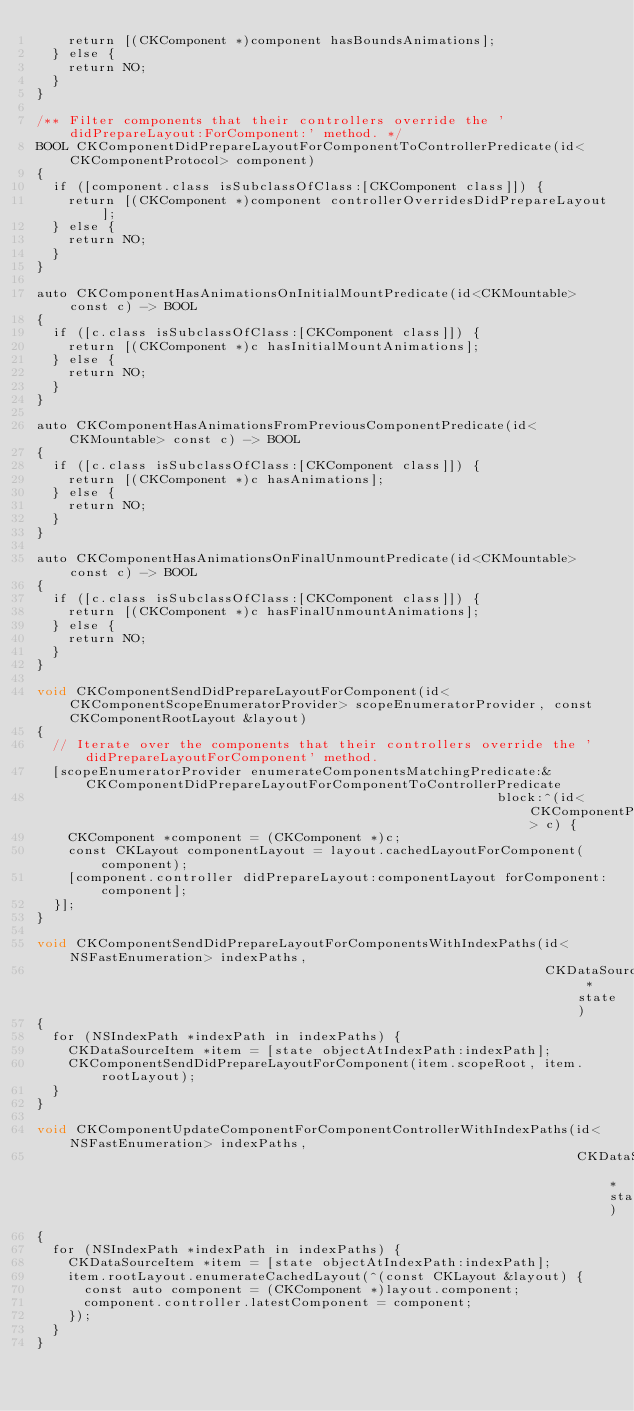Convert code to text. <code><loc_0><loc_0><loc_500><loc_500><_ObjectiveC_>    return [(CKComponent *)component hasBoundsAnimations];
  } else {
    return NO;
  }
}

/** Filter components that their controllers override the 'didPrepareLayout:ForComponent:' method. */
BOOL CKComponentDidPrepareLayoutForComponentToControllerPredicate(id<CKComponentProtocol> component)
{
  if ([component.class isSubclassOfClass:[CKComponent class]]) {
    return [(CKComponent *)component controllerOverridesDidPrepareLayout];
  } else {
    return NO;
  }
}

auto CKComponentHasAnimationsOnInitialMountPredicate(id<CKMountable> const c) -> BOOL
{
  if ([c.class isSubclassOfClass:[CKComponent class]]) {
    return [(CKComponent *)c hasInitialMountAnimations];
  } else {
    return NO;
  }
}

auto CKComponentHasAnimationsFromPreviousComponentPredicate(id<CKMountable> const c) -> BOOL
{
  if ([c.class isSubclassOfClass:[CKComponent class]]) {
    return [(CKComponent *)c hasAnimations];
  } else {
    return NO;
  }
}

auto CKComponentHasAnimationsOnFinalUnmountPredicate(id<CKMountable> const c) -> BOOL
{
  if ([c.class isSubclassOfClass:[CKComponent class]]) {
    return [(CKComponent *)c hasFinalUnmountAnimations];
  } else {
    return NO;
  }
}

void CKComponentSendDidPrepareLayoutForComponent(id<CKComponentScopeEnumeratorProvider> scopeEnumeratorProvider, const CKComponentRootLayout &layout)
{
  // Iterate over the components that their controllers override the 'didPrepareLayoutForComponent' method.
  [scopeEnumeratorProvider enumerateComponentsMatchingPredicate:&CKComponentDidPrepareLayoutForComponentToControllerPredicate
                                                          block:^(id<CKComponentProtocol> c) {
    CKComponent *component = (CKComponent *)c;
    const CKLayout componentLayout = layout.cachedLayoutForComponent(component);
    [component.controller didPrepareLayout:componentLayout forComponent:component];
  }];
}

void CKComponentSendDidPrepareLayoutForComponentsWithIndexPaths(id<NSFastEnumeration> indexPaths,
                                                                CKDataSourceState *state)
{
  for (NSIndexPath *indexPath in indexPaths) {
    CKDataSourceItem *item = [state objectAtIndexPath:indexPath];
    CKComponentSendDidPrepareLayoutForComponent(item.scopeRoot, item.rootLayout);
  }
}

void CKComponentUpdateComponentForComponentControllerWithIndexPaths(id<NSFastEnumeration> indexPaths,
                                                                    CKDataSourceState *state)
{
  for (NSIndexPath *indexPath in indexPaths) {
    CKDataSourceItem *item = [state objectAtIndexPath:indexPath];
    item.rootLayout.enumerateCachedLayout(^(const CKLayout &layout) {
      const auto component = (CKComponent *)layout.component;
      component.controller.latestComponent = component;
    });
  }
}
</code> 